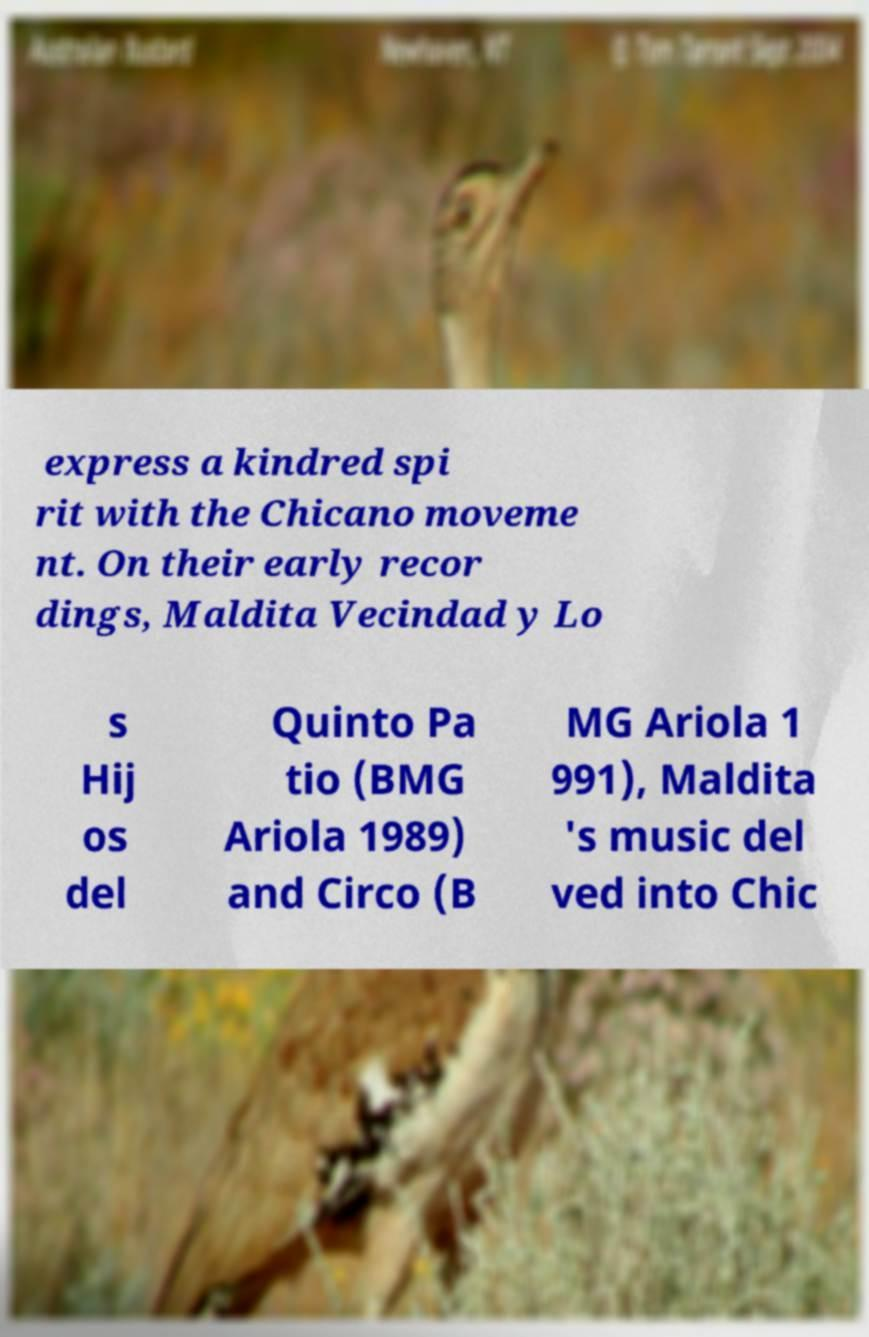Could you extract and type out the text from this image? express a kindred spi rit with the Chicano moveme nt. On their early recor dings, Maldita Vecindad y Lo s Hij os del Quinto Pa tio (BMG Ariola 1989) and Circo (B MG Ariola 1 991), Maldita 's music del ved into Chic 